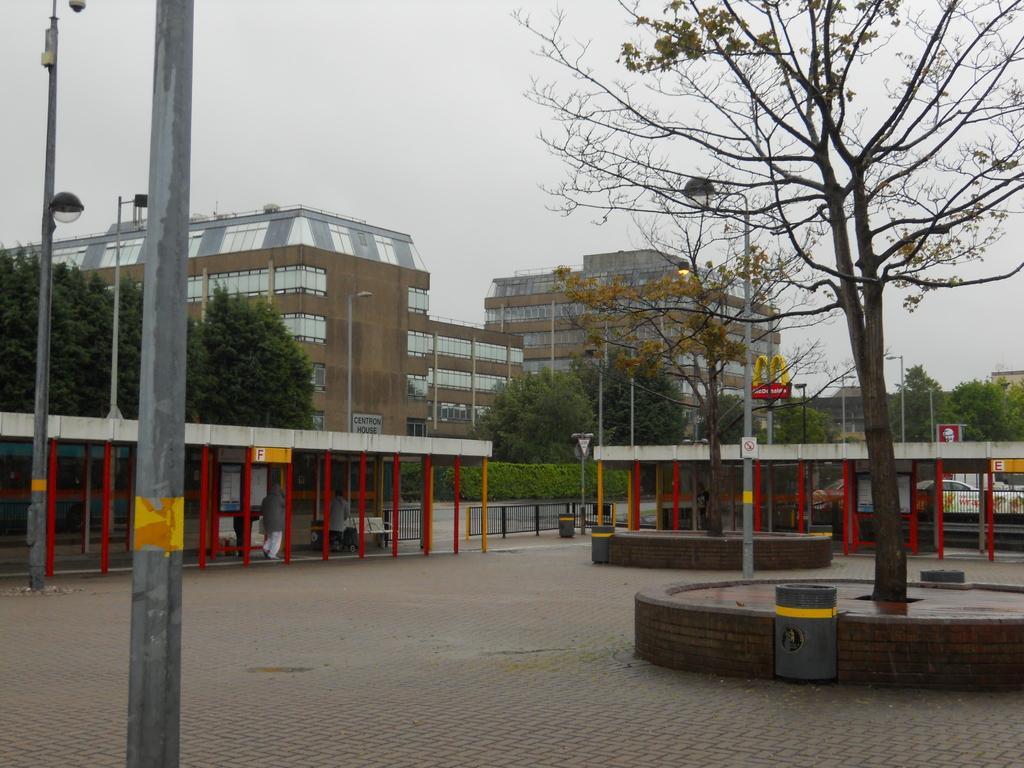Can you describe this image briefly? There is a pole, it seems like a trash bin and a tree in the foreground area of the image, there are trees, poles, buildings, sheds and the sky in the background. 